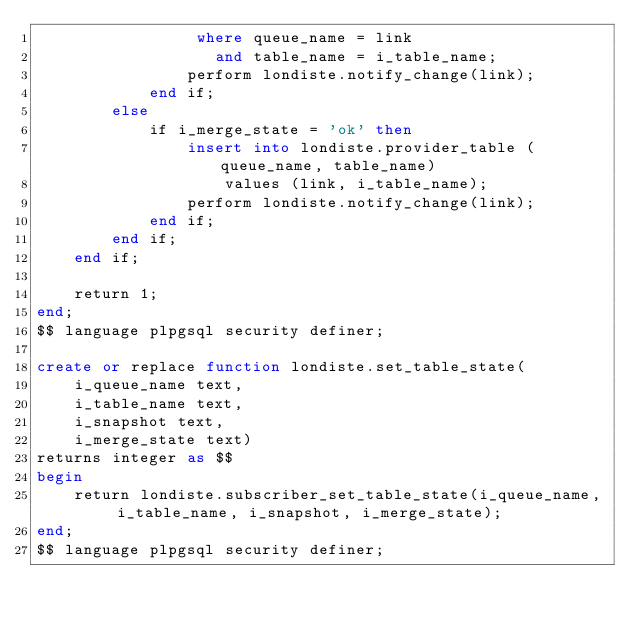Convert code to text. <code><loc_0><loc_0><loc_500><loc_500><_SQL_>                 where queue_name = link
                   and table_name = i_table_name;
                perform londiste.notify_change(link);
            end if;
        else
            if i_merge_state = 'ok' then
                insert into londiste.provider_table (queue_name, table_name)
                    values (link, i_table_name);
                perform londiste.notify_change(link);
            end if;
        end if;
    end if;

    return 1;
end;
$$ language plpgsql security definer;

create or replace function londiste.set_table_state(
    i_queue_name text,
    i_table_name text,
    i_snapshot text,
    i_merge_state text)
returns integer as $$
begin
    return londiste.subscriber_set_table_state(i_queue_name, i_table_name, i_snapshot, i_merge_state);
end;
$$ language plpgsql security definer;


</code> 